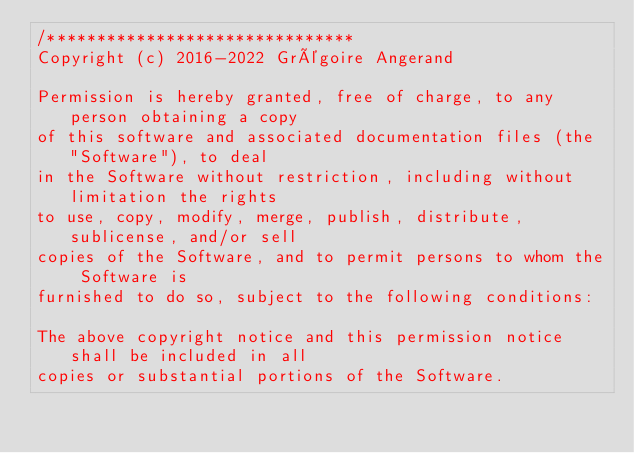<code> <loc_0><loc_0><loc_500><loc_500><_C++_>/*******************************
Copyright (c) 2016-2022 Grégoire Angerand

Permission is hereby granted, free of charge, to any person obtaining a copy
of this software and associated documentation files (the "Software"), to deal
in the Software without restriction, including without limitation the rights
to use, copy, modify, merge, publish, distribute, sublicense, and/or sell
copies of the Software, and to permit persons to whom the Software is
furnished to do so, subject to the following conditions:

The above copyright notice and this permission notice shall be included in all
copies or substantial portions of the Software.
</code> 